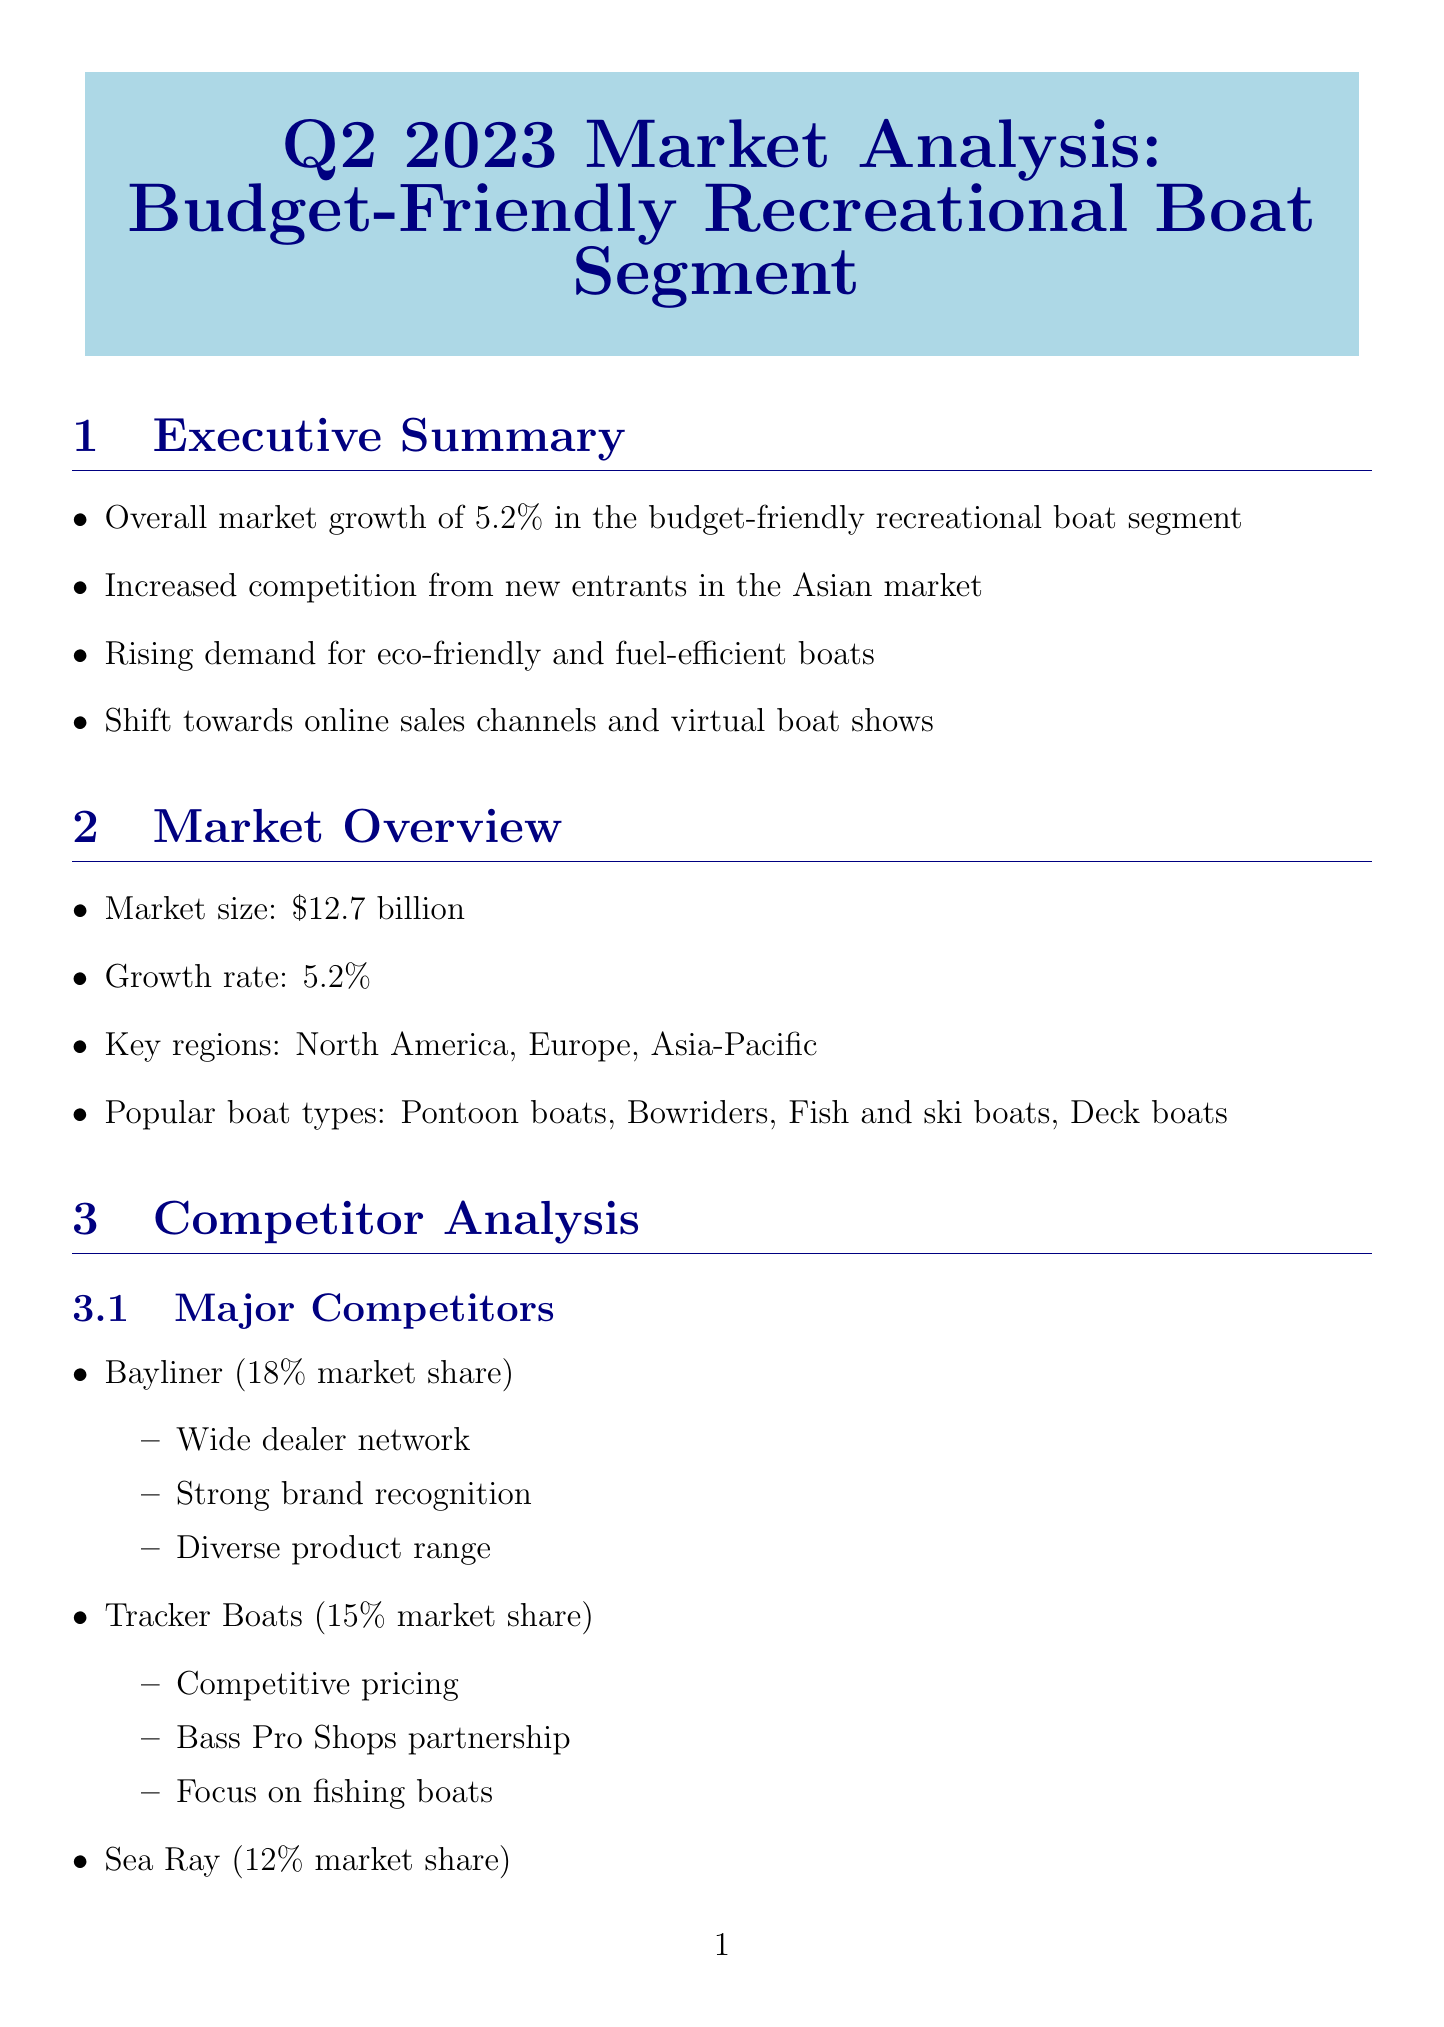What is the market size for budget-friendly recreational boats? The market size is indicated in the document as $12.7 billion.
Answer: $12.7 billion Which company has the highest market share? Bayliner is mentioned as having the highest market share at 18%.
Answer: Bayliner What trend involves the use of sustainable materials? The trend described is "Eco-friendly materials," which emphasizes recycled and sustainable materials in boat construction.
Answer: Eco-friendly materials What is the expected growth rate for the next five years? The document states the expected growth rate is a 6.5% CAGR over the next 5 years.
Answer: 6.5% CAGR Which region is identified as a key market? The document lists North America, Europe, and Asia-Pacific as key regions, mentioning them specifically.
Answer: North America, Europe, Asia-Pacific What is a key strength of Tracker Boats? The document highlights competitive pricing as a key strength of Tracker Boats.
Answer: Competitive pricing Which emerging company focuses on electric propulsion? EcoWave is identified as a new entrant that focuses on sustainable materials and electric propulsion.
Answer: EcoWave What are two major challenges anticipated in the market? The document identifies economic uncertainty and stricter environmental regulations as challenges.
Answer: Economic uncertainty, stricter environmental regulations What is the average customer age for recreational boat purchasers? The document specifies that the average customer age is between 35-55 years.
Answer: 35-55 years 